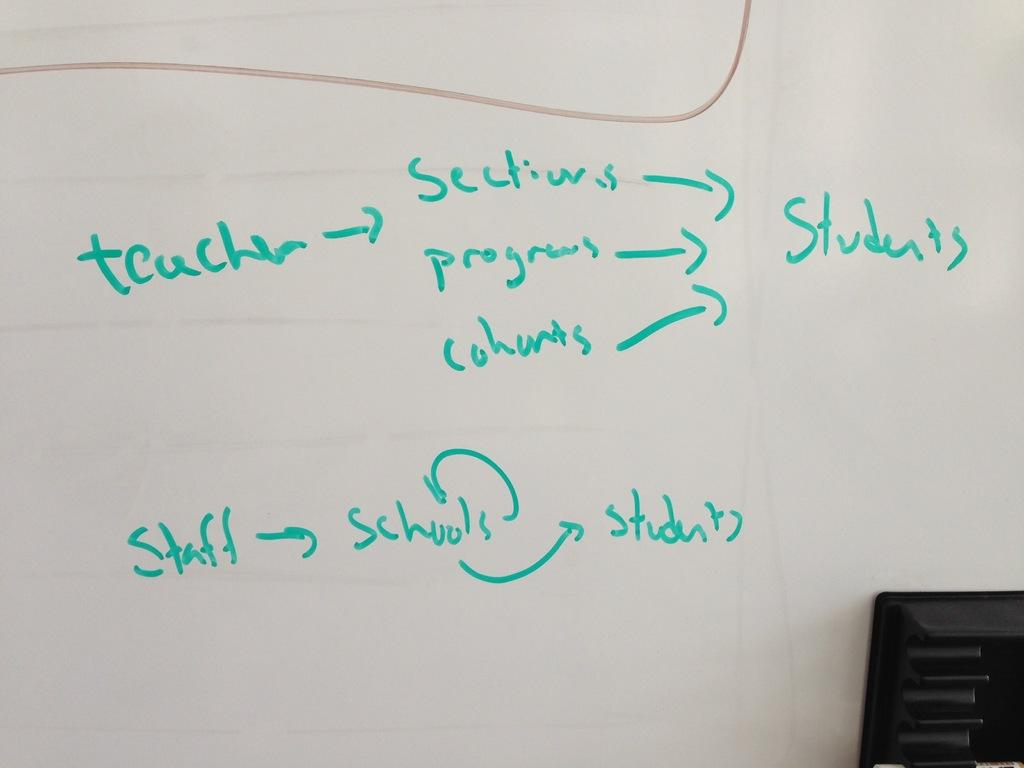<image>
Describe the image concisely. A white board connects several words, including teacher, staff, and students. 